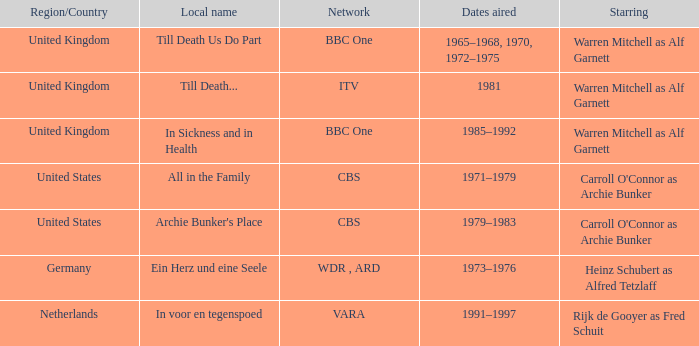What is the name of the network in the United Kingdom which aired in 1985–1992? BBC One. 